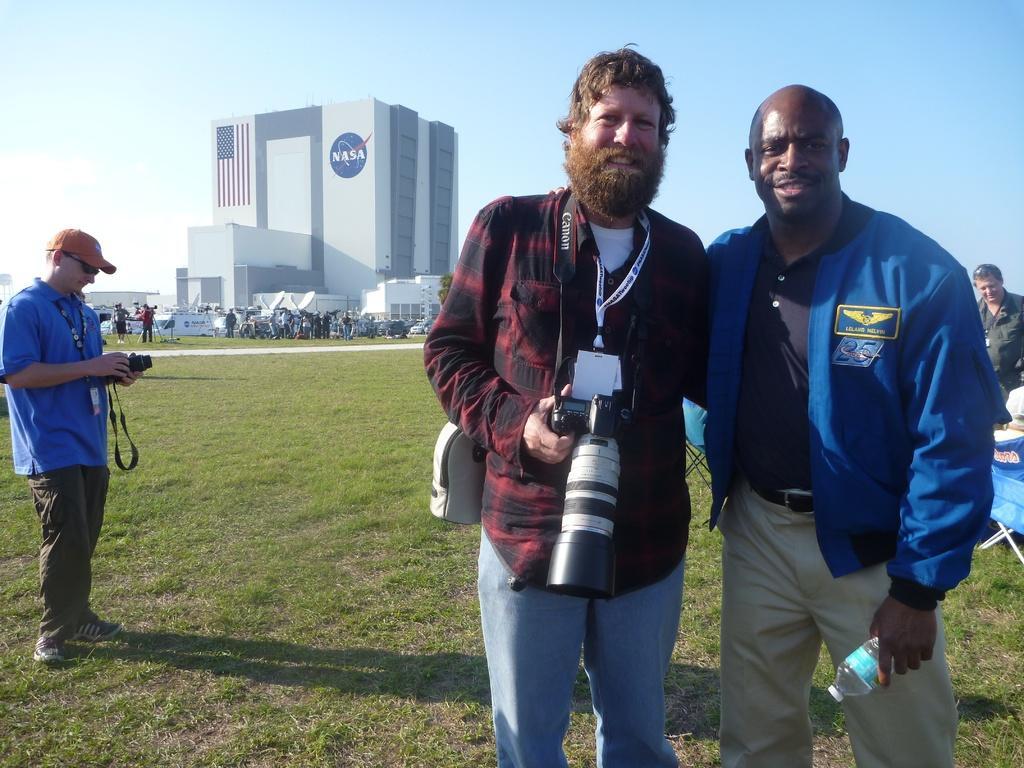In one or two sentences, can you explain what this image depicts? On the left there is a man standing on the ground by holding a camera in his hands. On the right there are two men standing by holding a camera and a bottle in their hand respectively. In the background there are few people,buildings,windows and sky. On the right there is a man standing at the table and on the table we can see some items. 